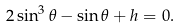<formula> <loc_0><loc_0><loc_500><loc_500>2 \sin ^ { 3 } \theta - \sin \theta + h = 0 .</formula> 